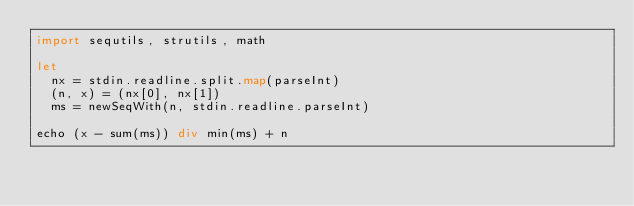Convert code to text. <code><loc_0><loc_0><loc_500><loc_500><_Nim_>import sequtils, strutils, math

let
  nx = stdin.readline.split.map(parseInt)
  (n, x) = (nx[0], nx[1])
  ms = newSeqWith(n, stdin.readline.parseInt)

echo (x - sum(ms)) div min(ms) + n
</code> 